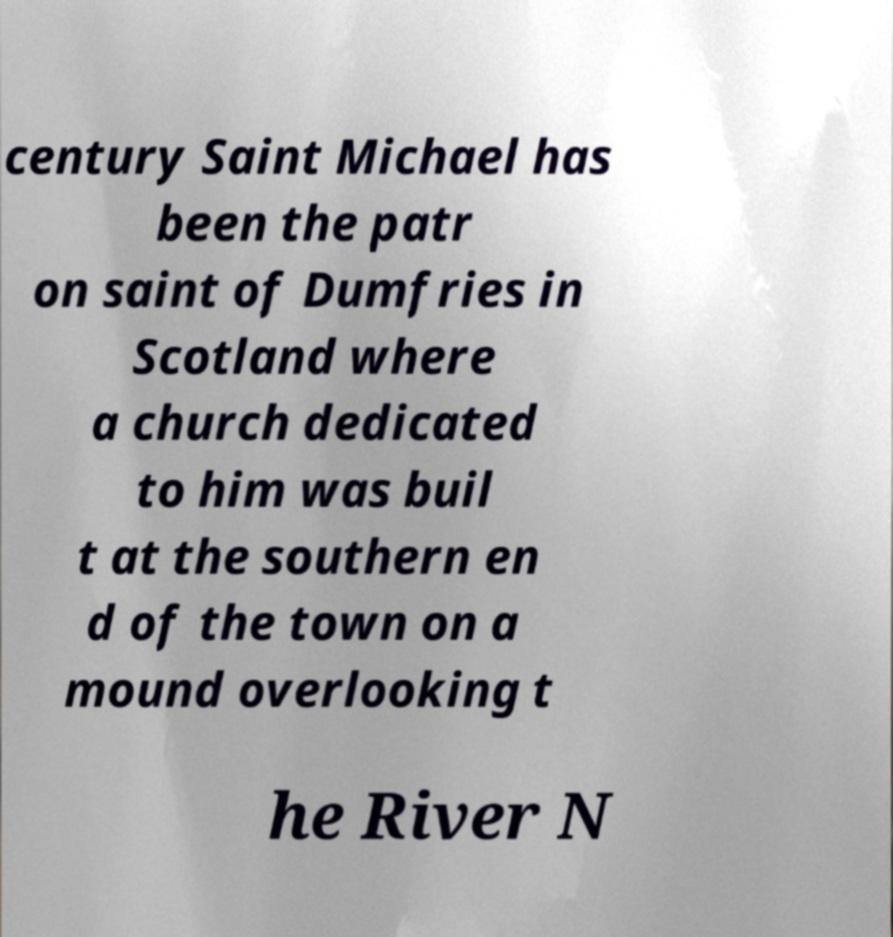Could you assist in decoding the text presented in this image and type it out clearly? century Saint Michael has been the patr on saint of Dumfries in Scotland where a church dedicated to him was buil t at the southern en d of the town on a mound overlooking t he River N 